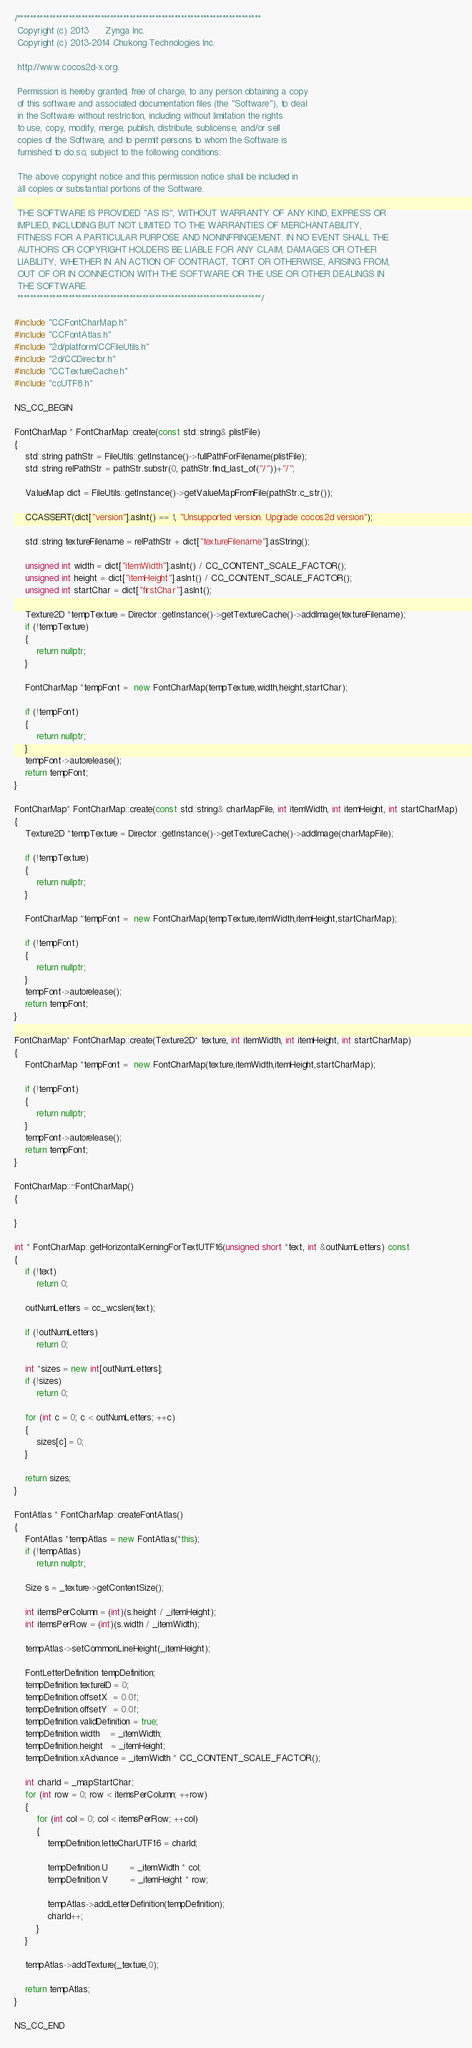Convert code to text. <code><loc_0><loc_0><loc_500><loc_500><_C++_>/****************************************************************************
 Copyright (c) 2013      Zynga Inc.
 Copyright (c) 2013-2014 Chukong Technologies Inc.
 
 http://www.cocos2d-x.org

 Permission is hereby granted, free of charge, to any person obtaining a copy
 of this software and associated documentation files (the "Software"), to deal
 in the Software without restriction, including without limitation the rights
 to use, copy, modify, merge, publish, distribute, sublicense, and/or sell
 copies of the Software, and to permit persons to whom the Software is
 furnished to do so, subject to the following conditions:

 The above copyright notice and this permission notice shall be included in
 all copies or substantial portions of the Software.

 THE SOFTWARE IS PROVIDED "AS IS", WITHOUT WARRANTY OF ANY KIND, EXPRESS OR
 IMPLIED, INCLUDING BUT NOT LIMITED TO THE WARRANTIES OF MERCHANTABILITY,
 FITNESS FOR A PARTICULAR PURPOSE AND NONINFRINGEMENT. IN NO EVENT SHALL THE
 AUTHORS OR COPYRIGHT HOLDERS BE LIABLE FOR ANY CLAIM, DAMAGES OR OTHER
 LIABILITY, WHETHER IN AN ACTION OF CONTRACT, TORT OR OTHERWISE, ARISING FROM,
 OUT OF OR IN CONNECTION WITH THE SOFTWARE OR THE USE OR OTHER DEALINGS IN
 THE SOFTWARE.
 ****************************************************************************/

#include "CCFontCharMap.h"
#include "CCFontAtlas.h"
#include "2d/platform/CCFileUtils.h"
#include "2d/CCDirector.h"
#include "CCTextureCache.h"
#include "ccUTF8.h"

NS_CC_BEGIN

FontCharMap * FontCharMap::create(const std::string& plistFile)
{
    std::string pathStr = FileUtils::getInstance()->fullPathForFilename(plistFile);
    std::string relPathStr = pathStr.substr(0, pathStr.find_last_of("/"))+"/";

    ValueMap dict = FileUtils::getInstance()->getValueMapFromFile(pathStr.c_str());

    CCASSERT(dict["version"].asInt() == 1, "Unsupported version. Upgrade cocos2d version");

    std::string textureFilename = relPathStr + dict["textureFilename"].asString();

    unsigned int width = dict["itemWidth"].asInt() / CC_CONTENT_SCALE_FACTOR();
    unsigned int height = dict["itemHeight"].asInt() / CC_CONTENT_SCALE_FACTOR();
    unsigned int startChar = dict["firstChar"].asInt();

    Texture2D *tempTexture = Director::getInstance()->getTextureCache()->addImage(textureFilename);
    if (!tempTexture)
    {
        return nullptr;
    }
    
    FontCharMap *tempFont =  new FontCharMap(tempTexture,width,height,startChar);
    
    if (!tempFont)
    {
        return nullptr;
    }
    tempFont->autorelease();
    return tempFont;
}

FontCharMap* FontCharMap::create(const std::string& charMapFile, int itemWidth, int itemHeight, int startCharMap)
{
    Texture2D *tempTexture = Director::getInstance()->getTextureCache()->addImage(charMapFile);

    if (!tempTexture)
    {
        return nullptr;
    }

    FontCharMap *tempFont =  new FontCharMap(tempTexture,itemWidth,itemHeight,startCharMap);

    if (!tempFont)
    {
        return nullptr;
    }
    tempFont->autorelease();
    return tempFont;
}

FontCharMap* FontCharMap::create(Texture2D* texture, int itemWidth, int itemHeight, int startCharMap)
{
    FontCharMap *tempFont =  new FontCharMap(texture,itemWidth,itemHeight,startCharMap);

    if (!tempFont)
    {
        return nullptr;
    }
    tempFont->autorelease();
    return tempFont;
}

FontCharMap::~FontCharMap()
{

}

int * FontCharMap::getHorizontalKerningForTextUTF16(unsigned short *text, int &outNumLetters) const
{
    if (!text)
        return 0;
    
    outNumLetters = cc_wcslen(text);
    
    if (!outNumLetters)
        return 0;
    
    int *sizes = new int[outNumLetters];
    if (!sizes)
        return 0;
    
    for (int c = 0; c < outNumLetters; ++c)
    {
        sizes[c] = 0;
    }
    
    return sizes;
}

FontAtlas * FontCharMap::createFontAtlas()
{
    FontAtlas *tempAtlas = new FontAtlas(*this);
    if (!tempAtlas)
        return nullptr;
    
    Size s = _texture->getContentSize();

    int itemsPerColumn = (int)(s.height / _itemHeight);
    int itemsPerRow = (int)(s.width / _itemWidth);

    tempAtlas->setCommonLineHeight(_itemHeight);
    
    FontLetterDefinition tempDefinition;
    tempDefinition.textureID = 0;
    tempDefinition.offsetX  = 0.0f;
    tempDefinition.offsetY  = 0.0f;
    tempDefinition.validDefinition = true;
    tempDefinition.width    = _itemWidth;
    tempDefinition.height   = _itemHeight;
    tempDefinition.xAdvance = _itemWidth * CC_CONTENT_SCALE_FACTOR();

    int charId = _mapStartChar;
    for (int row = 0; row < itemsPerColumn; ++row)
    {
        for (int col = 0; col < itemsPerRow; ++col)
        {
            tempDefinition.letteCharUTF16 = charId;

            tempDefinition.U        = _itemWidth * col;
            tempDefinition.V        = _itemHeight * row;           

            tempAtlas->addLetterDefinition(tempDefinition);
            charId++;
        }
    }
    
    tempAtlas->addTexture(_texture,0);

    return tempAtlas;
}

NS_CC_END</code> 